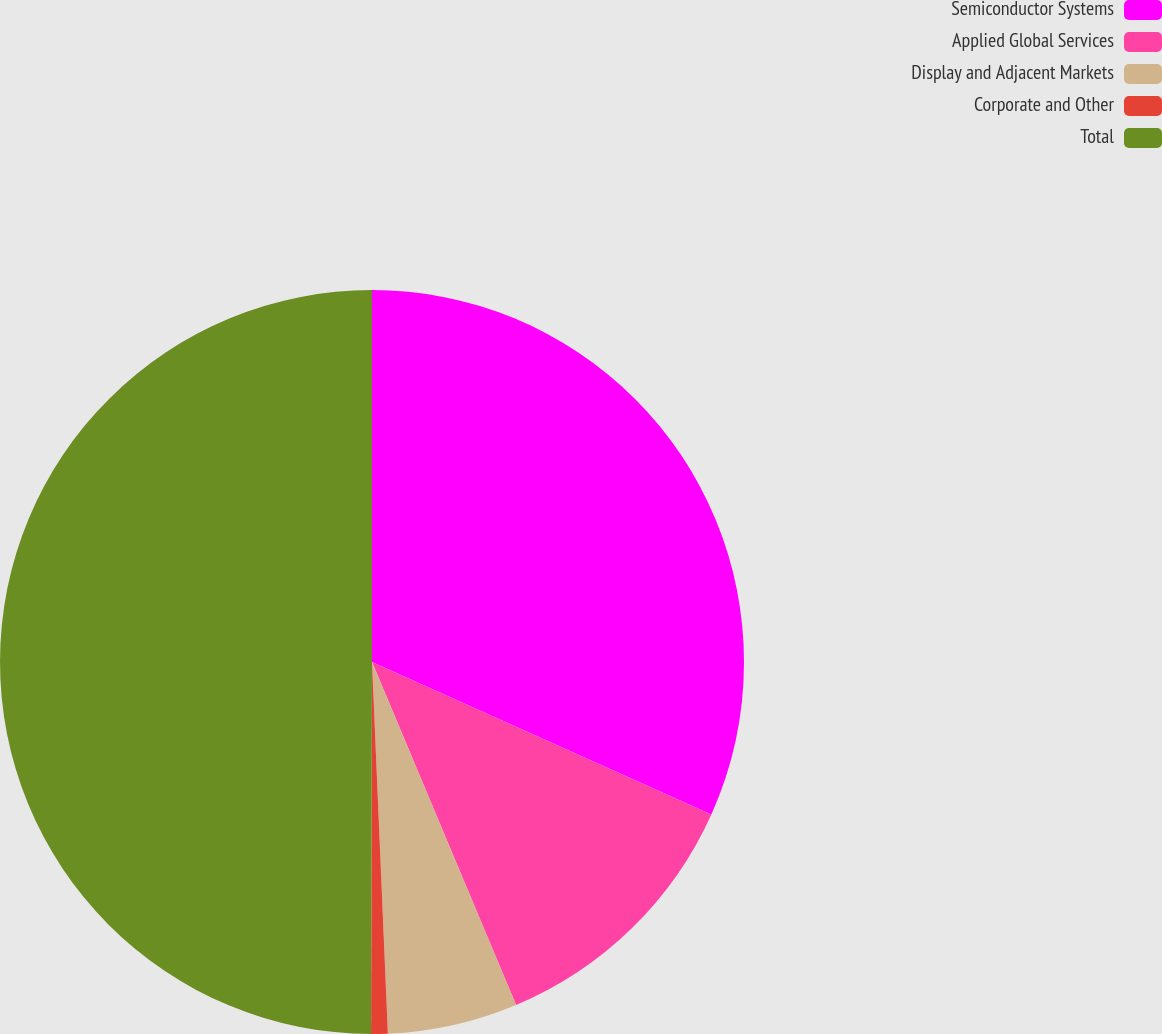Convert chart. <chart><loc_0><loc_0><loc_500><loc_500><pie_chart><fcel>Semiconductor Systems<fcel>Applied Global Services<fcel>Display and Adjacent Markets<fcel>Corporate and Other<fcel>Total<nl><fcel>31.72%<fcel>11.95%<fcel>5.65%<fcel>0.72%<fcel>49.96%<nl></chart> 